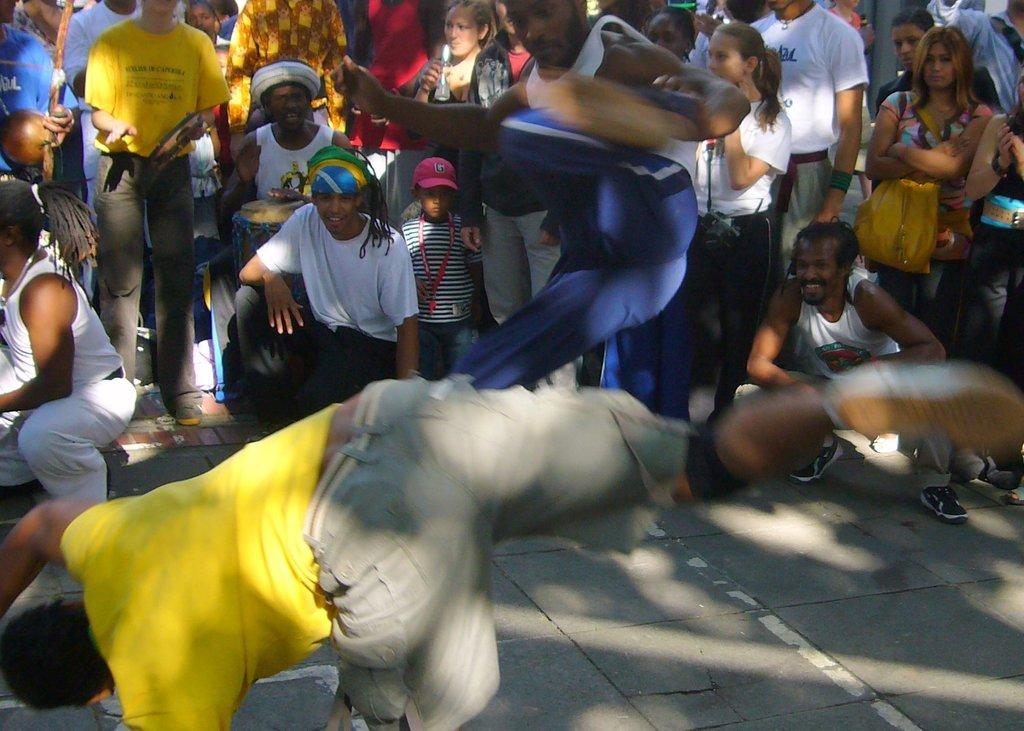What are the people in the image doing? There are people standing in the image, and two persons are dancing. Can you describe the actions of the dancing individuals? The two persons are dancing in the image. What type of insect can be seen flying around the dancers in the image? There is no insect present in the image; it only shows people standing and dancing. 